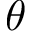<formula> <loc_0><loc_0><loc_500><loc_500>\theta</formula> 